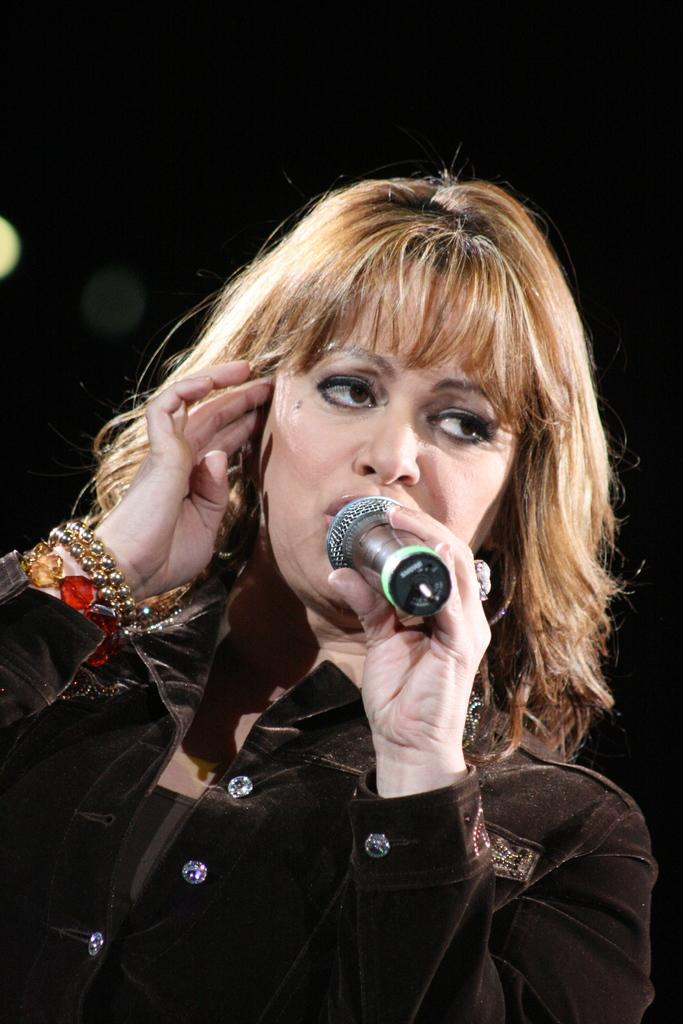What is the main subject of the image? The main subject of the image is a woman. What is the woman holding in the image? The woman is holding a mic. What type of land can be seen in the background of the image? There is no land visible in the image; it only features a woman holding a mic. How many letters are visible on the mic in the image? The image does not show any letters on the mic, so it is not possible to determine the number of letters. 